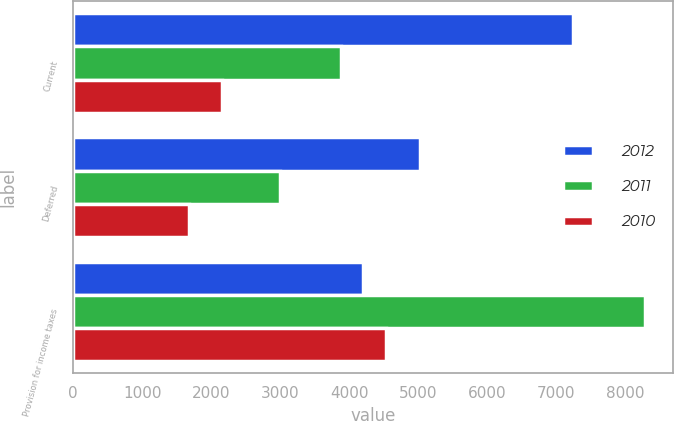Convert chart to OTSL. <chart><loc_0><loc_0><loc_500><loc_500><stacked_bar_chart><ecel><fcel>Current<fcel>Deferred<fcel>Provision for income taxes<nl><fcel>2012<fcel>7240<fcel>5018<fcel>4205.5<nl><fcel>2011<fcel>3884<fcel>2998<fcel>8283<nl><fcel>2010<fcel>2150<fcel>1676<fcel>4527<nl></chart> 